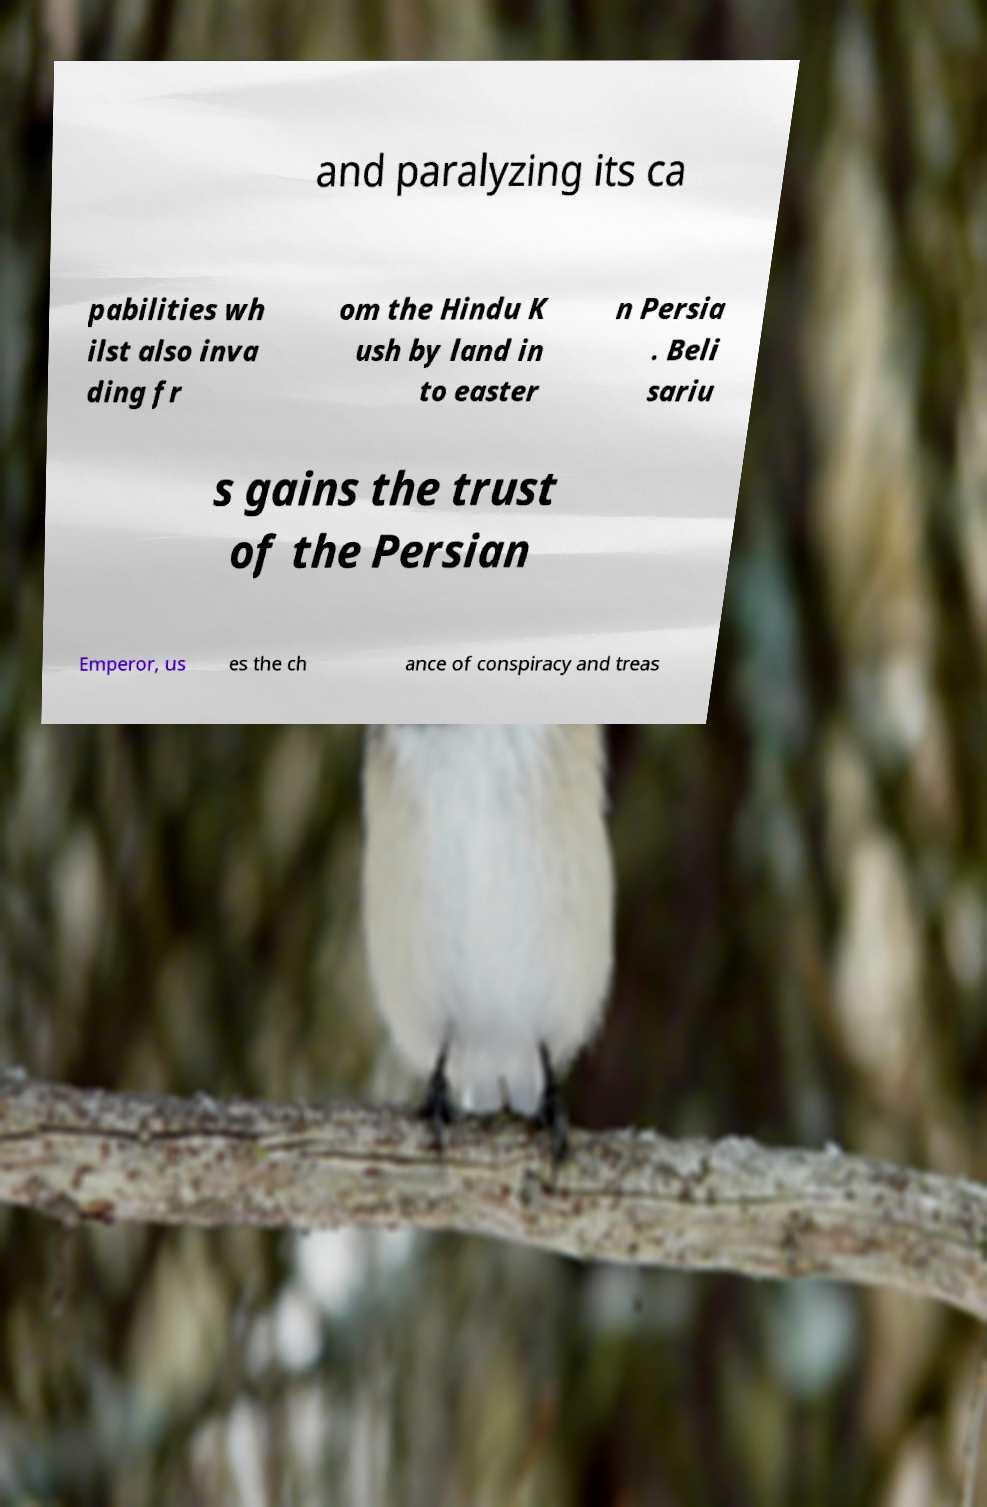There's text embedded in this image that I need extracted. Can you transcribe it verbatim? and paralyzing its ca pabilities wh ilst also inva ding fr om the Hindu K ush by land in to easter n Persia . Beli sariu s gains the trust of the Persian Emperor, us es the ch ance of conspiracy and treas 